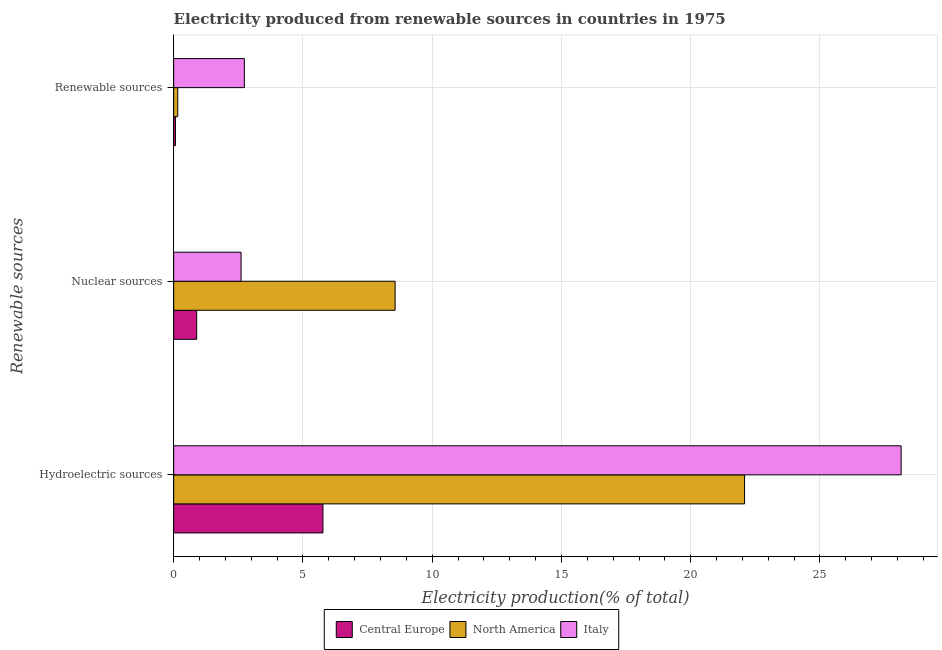How many different coloured bars are there?
Your response must be concise. 3. Are the number of bars on each tick of the Y-axis equal?
Give a very brief answer. Yes. How many bars are there on the 2nd tick from the top?
Ensure brevity in your answer.  3. What is the label of the 1st group of bars from the top?
Provide a short and direct response. Renewable sources. What is the percentage of electricity produced by renewable sources in Italy?
Provide a succinct answer. 2.73. Across all countries, what is the maximum percentage of electricity produced by nuclear sources?
Your answer should be compact. 8.57. Across all countries, what is the minimum percentage of electricity produced by nuclear sources?
Make the answer very short. 0.89. In which country was the percentage of electricity produced by hydroelectric sources maximum?
Provide a short and direct response. Italy. In which country was the percentage of electricity produced by renewable sources minimum?
Your response must be concise. Central Europe. What is the total percentage of electricity produced by renewable sources in the graph?
Provide a succinct answer. 2.96. What is the difference between the percentage of electricity produced by renewable sources in Italy and that in North America?
Your answer should be compact. 2.58. What is the difference between the percentage of electricity produced by renewable sources in Italy and the percentage of electricity produced by hydroelectric sources in North America?
Your response must be concise. -19.35. What is the average percentage of electricity produced by nuclear sources per country?
Offer a terse response. 4.02. What is the difference between the percentage of electricity produced by renewable sources and percentage of electricity produced by hydroelectric sources in North America?
Offer a terse response. -21.93. In how many countries, is the percentage of electricity produced by renewable sources greater than 12 %?
Provide a short and direct response. 0. What is the ratio of the percentage of electricity produced by hydroelectric sources in North America to that in Central Europe?
Offer a very short reply. 3.82. What is the difference between the highest and the second highest percentage of electricity produced by nuclear sources?
Provide a succinct answer. 5.96. What is the difference between the highest and the lowest percentage of electricity produced by nuclear sources?
Give a very brief answer. 7.68. In how many countries, is the percentage of electricity produced by nuclear sources greater than the average percentage of electricity produced by nuclear sources taken over all countries?
Offer a very short reply. 1. What does the 3rd bar from the top in Renewable sources represents?
Provide a short and direct response. Central Europe. What does the 1st bar from the bottom in Nuclear sources represents?
Your answer should be very brief. Central Europe. Is it the case that in every country, the sum of the percentage of electricity produced by hydroelectric sources and percentage of electricity produced by nuclear sources is greater than the percentage of electricity produced by renewable sources?
Keep it short and to the point. Yes. How many countries are there in the graph?
Provide a succinct answer. 3. Does the graph contain any zero values?
Your answer should be compact. No. What is the title of the graph?
Offer a very short reply. Electricity produced from renewable sources in countries in 1975. What is the label or title of the X-axis?
Provide a short and direct response. Electricity production(% of total). What is the label or title of the Y-axis?
Offer a terse response. Renewable sources. What is the Electricity production(% of total) of Central Europe in Hydroelectric sources?
Give a very brief answer. 5.77. What is the Electricity production(% of total) in North America in Hydroelectric sources?
Offer a terse response. 22.08. What is the Electricity production(% of total) in Italy in Hydroelectric sources?
Provide a short and direct response. 28.14. What is the Electricity production(% of total) in Central Europe in Nuclear sources?
Offer a very short reply. 0.89. What is the Electricity production(% of total) in North America in Nuclear sources?
Make the answer very short. 8.57. What is the Electricity production(% of total) in Italy in Nuclear sources?
Your answer should be compact. 2.61. What is the Electricity production(% of total) in Central Europe in Renewable sources?
Offer a very short reply. 0.07. What is the Electricity production(% of total) in North America in Renewable sources?
Your answer should be very brief. 0.16. What is the Electricity production(% of total) of Italy in Renewable sources?
Provide a succinct answer. 2.73. Across all Renewable sources, what is the maximum Electricity production(% of total) of Central Europe?
Offer a very short reply. 5.77. Across all Renewable sources, what is the maximum Electricity production(% of total) in North America?
Offer a terse response. 22.08. Across all Renewable sources, what is the maximum Electricity production(% of total) of Italy?
Your response must be concise. 28.14. Across all Renewable sources, what is the minimum Electricity production(% of total) of Central Europe?
Offer a very short reply. 0.07. Across all Renewable sources, what is the minimum Electricity production(% of total) of North America?
Your answer should be compact. 0.16. Across all Renewable sources, what is the minimum Electricity production(% of total) in Italy?
Make the answer very short. 2.61. What is the total Electricity production(% of total) in Central Europe in the graph?
Offer a very short reply. 6.73. What is the total Electricity production(% of total) of North America in the graph?
Give a very brief answer. 30.81. What is the total Electricity production(% of total) in Italy in the graph?
Keep it short and to the point. 33.48. What is the difference between the Electricity production(% of total) of Central Europe in Hydroelectric sources and that in Nuclear sources?
Keep it short and to the point. 4.88. What is the difference between the Electricity production(% of total) of North America in Hydroelectric sources and that in Nuclear sources?
Provide a short and direct response. 13.52. What is the difference between the Electricity production(% of total) of Italy in Hydroelectric sources and that in Nuclear sources?
Offer a terse response. 25.53. What is the difference between the Electricity production(% of total) of Central Europe in Hydroelectric sources and that in Renewable sources?
Provide a short and direct response. 5.71. What is the difference between the Electricity production(% of total) in North America in Hydroelectric sources and that in Renewable sources?
Make the answer very short. 21.93. What is the difference between the Electricity production(% of total) in Italy in Hydroelectric sources and that in Renewable sources?
Keep it short and to the point. 25.41. What is the difference between the Electricity production(% of total) of Central Europe in Nuclear sources and that in Renewable sources?
Make the answer very short. 0.82. What is the difference between the Electricity production(% of total) in North America in Nuclear sources and that in Renewable sources?
Your answer should be very brief. 8.41. What is the difference between the Electricity production(% of total) of Italy in Nuclear sources and that in Renewable sources?
Your answer should be compact. -0.13. What is the difference between the Electricity production(% of total) of Central Europe in Hydroelectric sources and the Electricity production(% of total) of North America in Nuclear sources?
Provide a short and direct response. -2.79. What is the difference between the Electricity production(% of total) in Central Europe in Hydroelectric sources and the Electricity production(% of total) in Italy in Nuclear sources?
Make the answer very short. 3.17. What is the difference between the Electricity production(% of total) in North America in Hydroelectric sources and the Electricity production(% of total) in Italy in Nuclear sources?
Offer a very short reply. 19.48. What is the difference between the Electricity production(% of total) of Central Europe in Hydroelectric sources and the Electricity production(% of total) of North America in Renewable sources?
Give a very brief answer. 5.62. What is the difference between the Electricity production(% of total) in Central Europe in Hydroelectric sources and the Electricity production(% of total) in Italy in Renewable sources?
Your answer should be compact. 3.04. What is the difference between the Electricity production(% of total) in North America in Hydroelectric sources and the Electricity production(% of total) in Italy in Renewable sources?
Give a very brief answer. 19.35. What is the difference between the Electricity production(% of total) in Central Europe in Nuclear sources and the Electricity production(% of total) in North America in Renewable sources?
Provide a succinct answer. 0.73. What is the difference between the Electricity production(% of total) in Central Europe in Nuclear sources and the Electricity production(% of total) in Italy in Renewable sources?
Give a very brief answer. -1.84. What is the difference between the Electricity production(% of total) of North America in Nuclear sources and the Electricity production(% of total) of Italy in Renewable sources?
Offer a terse response. 5.83. What is the average Electricity production(% of total) of Central Europe per Renewable sources?
Keep it short and to the point. 2.24. What is the average Electricity production(% of total) of North America per Renewable sources?
Ensure brevity in your answer.  10.27. What is the average Electricity production(% of total) of Italy per Renewable sources?
Provide a succinct answer. 11.16. What is the difference between the Electricity production(% of total) of Central Europe and Electricity production(% of total) of North America in Hydroelectric sources?
Your answer should be very brief. -16.31. What is the difference between the Electricity production(% of total) in Central Europe and Electricity production(% of total) in Italy in Hydroelectric sources?
Make the answer very short. -22.37. What is the difference between the Electricity production(% of total) in North America and Electricity production(% of total) in Italy in Hydroelectric sources?
Your response must be concise. -6.06. What is the difference between the Electricity production(% of total) of Central Europe and Electricity production(% of total) of North America in Nuclear sources?
Your response must be concise. -7.68. What is the difference between the Electricity production(% of total) of Central Europe and Electricity production(% of total) of Italy in Nuclear sources?
Ensure brevity in your answer.  -1.72. What is the difference between the Electricity production(% of total) of North America and Electricity production(% of total) of Italy in Nuclear sources?
Keep it short and to the point. 5.96. What is the difference between the Electricity production(% of total) in Central Europe and Electricity production(% of total) in North America in Renewable sources?
Offer a very short reply. -0.09. What is the difference between the Electricity production(% of total) of Central Europe and Electricity production(% of total) of Italy in Renewable sources?
Provide a succinct answer. -2.67. What is the difference between the Electricity production(% of total) in North America and Electricity production(% of total) in Italy in Renewable sources?
Your response must be concise. -2.58. What is the ratio of the Electricity production(% of total) of Central Europe in Hydroelectric sources to that in Nuclear sources?
Offer a terse response. 6.49. What is the ratio of the Electricity production(% of total) in North America in Hydroelectric sources to that in Nuclear sources?
Ensure brevity in your answer.  2.58. What is the ratio of the Electricity production(% of total) in Italy in Hydroelectric sources to that in Nuclear sources?
Your answer should be very brief. 10.79. What is the ratio of the Electricity production(% of total) of Central Europe in Hydroelectric sources to that in Renewable sources?
Your response must be concise. 84.28. What is the ratio of the Electricity production(% of total) of North America in Hydroelectric sources to that in Renewable sources?
Your response must be concise. 139.42. What is the ratio of the Electricity production(% of total) of Italy in Hydroelectric sources to that in Renewable sources?
Offer a terse response. 10.29. What is the ratio of the Electricity production(% of total) of Central Europe in Nuclear sources to that in Renewable sources?
Offer a terse response. 12.99. What is the ratio of the Electricity production(% of total) of North America in Nuclear sources to that in Renewable sources?
Keep it short and to the point. 54.08. What is the ratio of the Electricity production(% of total) of Italy in Nuclear sources to that in Renewable sources?
Your answer should be compact. 0.95. What is the difference between the highest and the second highest Electricity production(% of total) of Central Europe?
Give a very brief answer. 4.88. What is the difference between the highest and the second highest Electricity production(% of total) of North America?
Offer a very short reply. 13.52. What is the difference between the highest and the second highest Electricity production(% of total) in Italy?
Make the answer very short. 25.41. What is the difference between the highest and the lowest Electricity production(% of total) in Central Europe?
Provide a succinct answer. 5.71. What is the difference between the highest and the lowest Electricity production(% of total) of North America?
Give a very brief answer. 21.93. What is the difference between the highest and the lowest Electricity production(% of total) of Italy?
Provide a short and direct response. 25.53. 